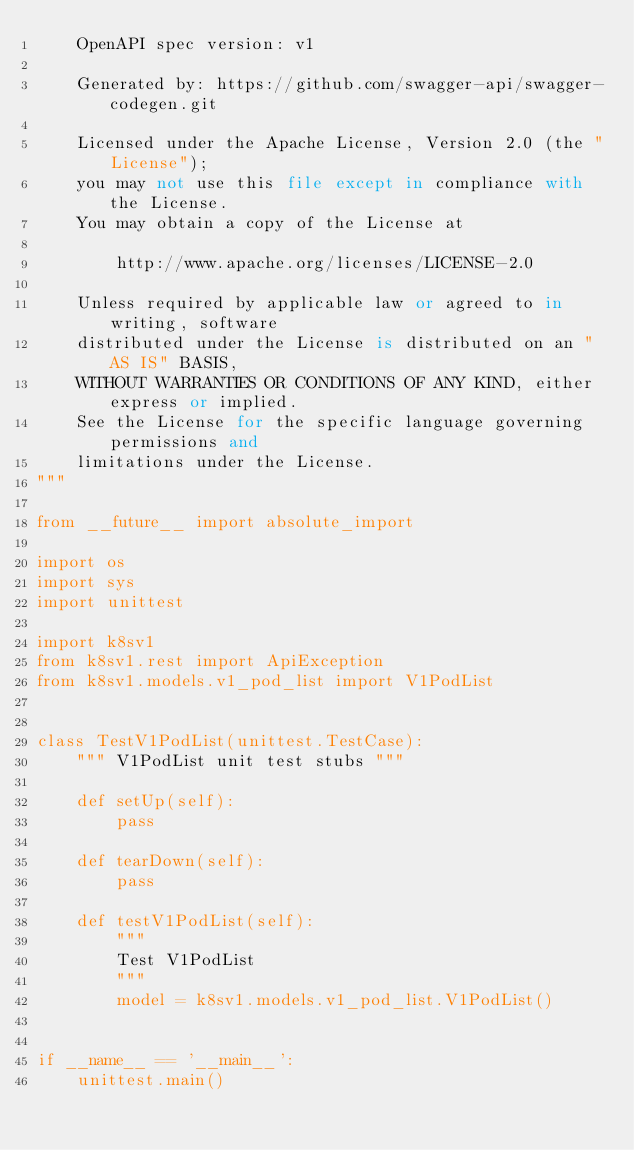<code> <loc_0><loc_0><loc_500><loc_500><_Python_>    OpenAPI spec version: v1
    
    Generated by: https://github.com/swagger-api/swagger-codegen.git

    Licensed under the Apache License, Version 2.0 (the "License");
    you may not use this file except in compliance with the License.
    You may obtain a copy of the License at

        http://www.apache.org/licenses/LICENSE-2.0

    Unless required by applicable law or agreed to in writing, software
    distributed under the License is distributed on an "AS IS" BASIS,
    WITHOUT WARRANTIES OR CONDITIONS OF ANY KIND, either express or implied.
    See the License for the specific language governing permissions and
    limitations under the License.
"""

from __future__ import absolute_import

import os
import sys
import unittest

import k8sv1
from k8sv1.rest import ApiException
from k8sv1.models.v1_pod_list import V1PodList


class TestV1PodList(unittest.TestCase):
    """ V1PodList unit test stubs """

    def setUp(self):
        pass

    def tearDown(self):
        pass

    def testV1PodList(self):
        """
        Test V1PodList
        """
        model = k8sv1.models.v1_pod_list.V1PodList()


if __name__ == '__main__':
    unittest.main()
</code> 